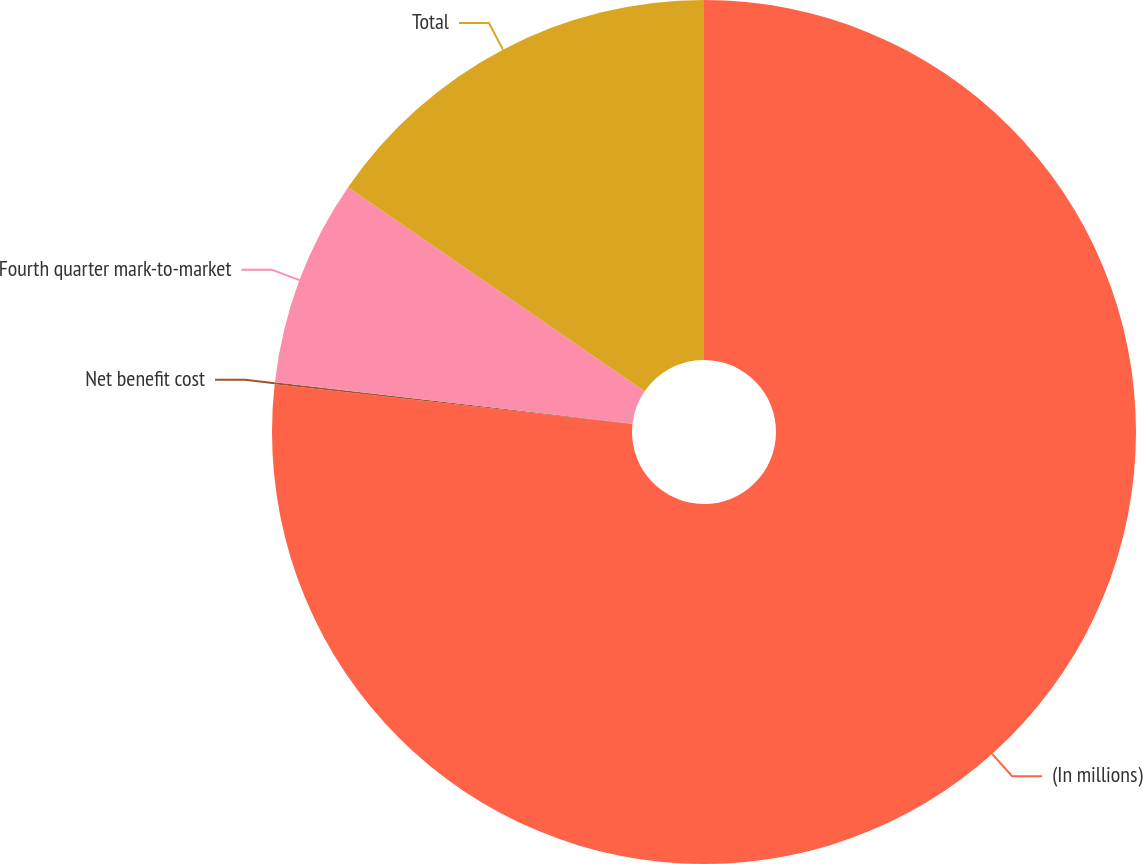<chart> <loc_0><loc_0><loc_500><loc_500><pie_chart><fcel>(In millions)<fcel>Net benefit cost<fcel>Fourth quarter mark-to-market<fcel>Total<nl><fcel>76.76%<fcel>0.08%<fcel>7.75%<fcel>15.41%<nl></chart> 